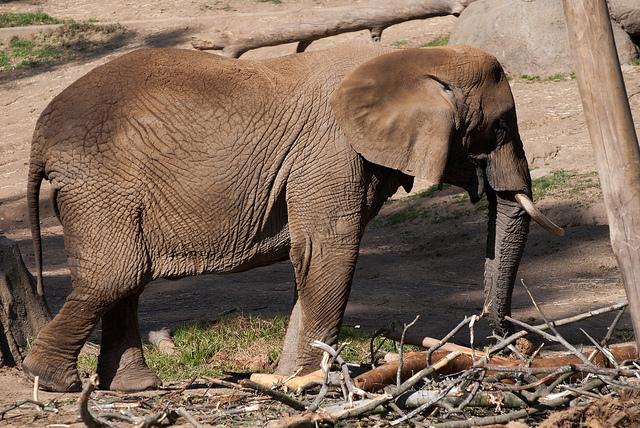What color is this elephant?
Quick response, please. Gray. How tall is the baby elephant?
Give a very brief answer. 5 feet. What type of animal is pictured?
Short answer required. Elephant. What color is the background?
Keep it brief. Brown. Which leg does the elephant not have weight on?
Be succinct. Back right. How many of its tusks are visible?
Short answer required. 1. Is the elephant's eye open?
Quick response, please. Yes. Is the elephant walking?
Short answer required. Yes. 